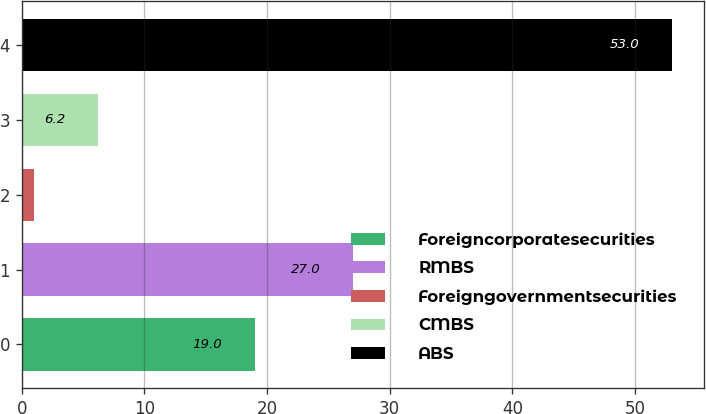Convert chart to OTSL. <chart><loc_0><loc_0><loc_500><loc_500><bar_chart><fcel>Foreigncorporatesecurities<fcel>RMBS<fcel>Foreigngovernmentsecurities<fcel>CMBS<fcel>ABS<nl><fcel>19<fcel>27<fcel>1<fcel>6.2<fcel>53<nl></chart> 